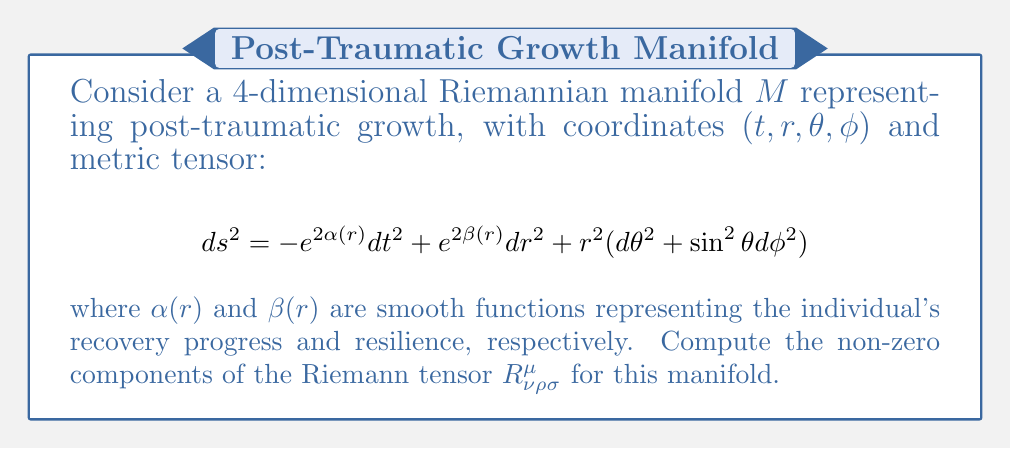Can you solve this math problem? To compute the Riemann tensor, we'll follow these steps:

1) First, we need to calculate the Christoffel symbols $\Gamma^{\mu}_{\nu\rho}$ using the formula:

   $$\Gamma^{\mu}_{\nu\rho} = \frac{1}{2}g^{\mu\sigma}(\partial_\nu g_{\sigma\rho} + \partial_\rho g_{\sigma\nu} - \partial_\sigma g_{\nu\rho})$$

2) The non-zero Christoffel symbols for this metric are:

   $$\Gamma^t_{tr} = \alpha'(r)$$
   $$\Gamma^r_{tt} = e^{2(\alpha(r)-\beta(r))}\alpha'(r)$$
   $$\Gamma^r_{rr} = \beta'(r)$$
   $$\Gamma^r_{\theta\theta} = -re^{-2\beta(r)}$$
   $$\Gamma^r_{\phi\phi} = -re^{-2\beta(r)}\sin^2\theta$$
   $$\Gamma^\theta_{r\theta} = \Gamma^\phi_{r\phi} = \frac{1}{r}$$
   $$\Gamma^\theta_{\phi\phi} = -\sin\theta\cos\theta$$
   $$\Gamma^\phi_{\theta\phi} = \cot\theta$$

3) Now, we can compute the Riemann tensor using the formula:

   $$R^{\mu}_{\nu\rho\sigma} = \partial_\rho \Gamma^{\mu}_{\nu\sigma} - \partial_\sigma \Gamma^{\mu}_{\nu\rho} + \Gamma^{\mu}_{\lambda\rho}\Gamma^{\lambda}_{\nu\sigma} - \Gamma^{\mu}_{\lambda\sigma}\Gamma^{\lambda}_{\nu\rho}$$

4) The non-zero components of the Riemann tensor are:

   $$R^t_{rtr} = \alpha''(r) + (\alpha'(r))^2 - \alpha'(r)\beta'(r)$$
   $$R^r_{trt} = -e^{2(\alpha(r)-\beta(r))}(\alpha''(r) + (\alpha'(r))^2 - \alpha'(r)\beta'(r))$$
   $$R^r_{\theta r\theta} = R^r_{\phi r\phi} = -e^{-2\beta(r)}(1 + r\beta'(r))$$
   $$R^\theta_{\phi\theta\phi} = (1 - e^{-2\beta(r)})\sin^2\theta$$

5) These components represent the curvature of the manifold, which in this context could be interpreted as the complexity and non-linearity of the post-traumatic growth process.
Answer: $R^t_{rtr} = \alpha''(r) + (\alpha'(r))^2 - \alpha'(r)\beta'(r)$
$R^r_{trt} = -e^{2(\alpha(r)-\beta(r))}(\alpha''(r) + (\alpha'(r))^2 - \alpha'(r)\beta'(r))$
$R^r_{\theta r\theta} = R^r_{\phi r\phi} = -e^{-2\beta(r)}(1 + r\beta'(r))$
$R^\theta_{\phi\theta\phi} = (1 - e^{-2\beta(r)})\sin^2\theta$ 